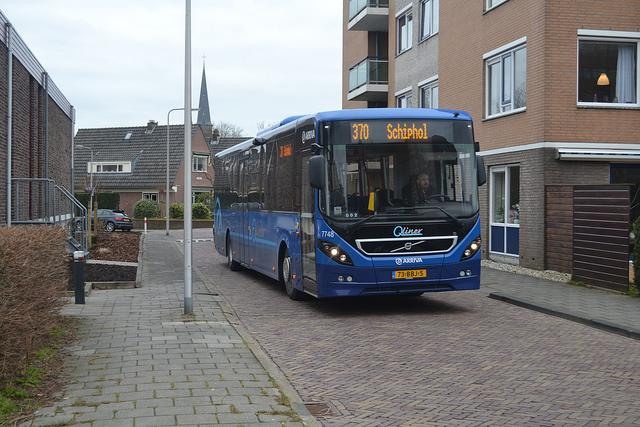What do people do inside the building with the spire on it? Please explain your reasoning. worship. The building with a spire is a church. people pray inside it. 